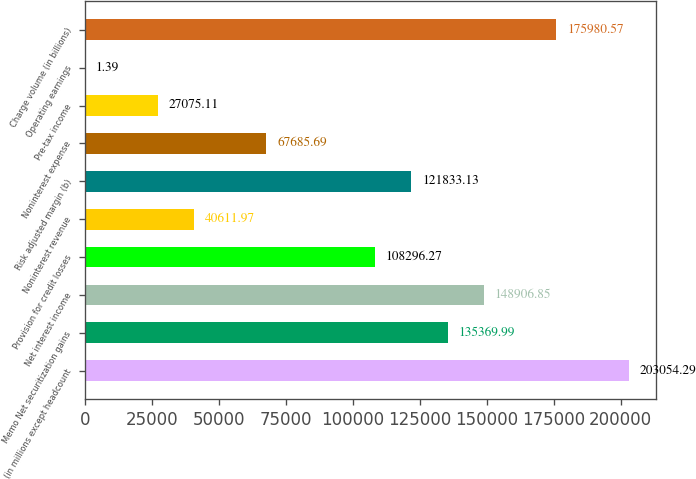Convert chart to OTSL. <chart><loc_0><loc_0><loc_500><loc_500><bar_chart><fcel>(in millions except headcount<fcel>Memo Net securitization gains<fcel>Net interest income<fcel>Provision for credit losses<fcel>Noninterest revenue<fcel>Risk adjusted margin (b)<fcel>Noninterest expense<fcel>Pre-tax income<fcel>Operating earnings<fcel>Charge volume (in billions)<nl><fcel>203054<fcel>135370<fcel>148907<fcel>108296<fcel>40612<fcel>121833<fcel>67685.7<fcel>27075.1<fcel>1.39<fcel>175981<nl></chart> 